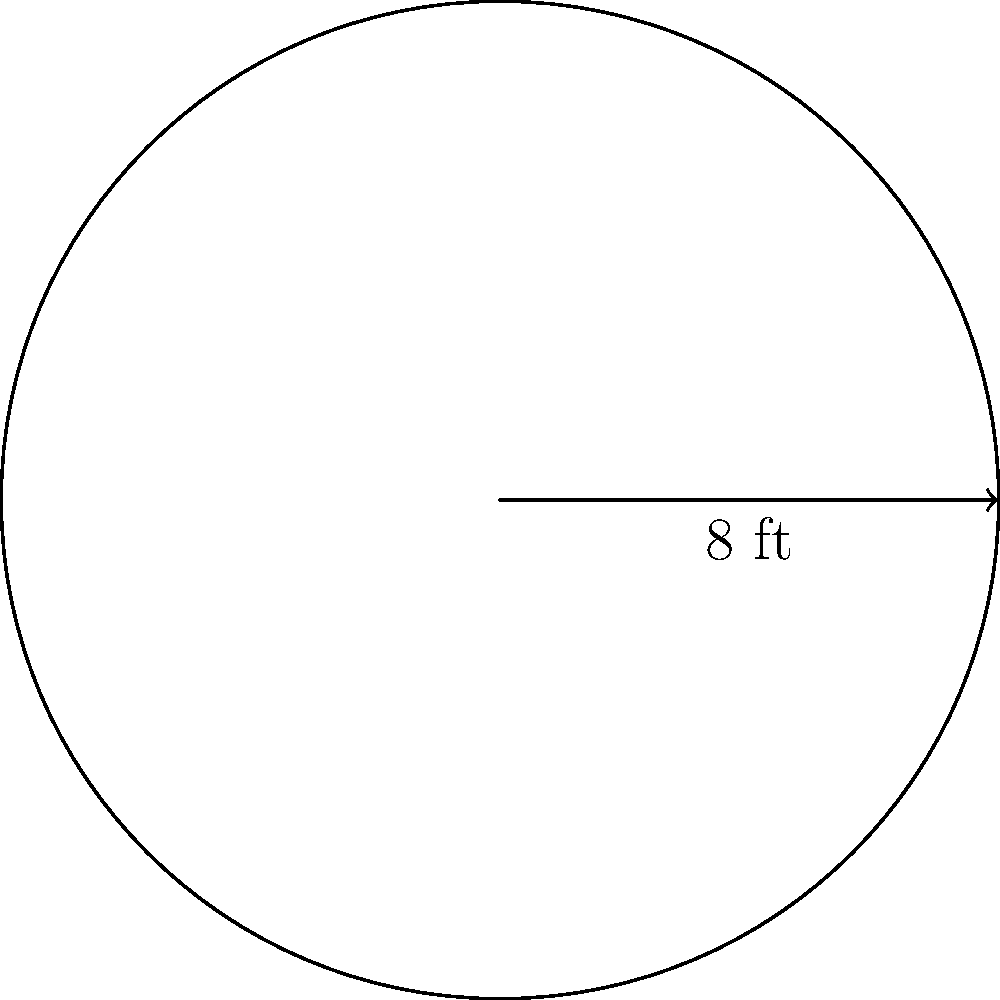As a proud American manufacturer, you're expanding your storage capacity. You need to calculate the floor area of a new circular storage tank for your Trump-supporting business. If the tank has a diameter of 8 feet, what is its floor area in square feet? Round your answer to the nearest whole number. Let's approach this step-by-step:

1) The formula for the area of a circle is $A = \pi r^2$, where $r$ is the radius.

2) We're given the diameter, which is 8 feet. The radius is half of the diameter:
   $r = 8 \div 2 = 4$ feet

3) Now, let's substitute this into our formula:
   $A = \pi (4)^2$

4) Simplify:
   $A = \pi (16)$
   $A = 16\pi$

5) Using $\pi \approx 3.14159$, we get:
   $A \approx 16 * 3.14159 = 50.26544$ square feet

6) Rounding to the nearest whole number:
   $A \approx 50$ square feet

This new storage tank will provide ample space for your American-made products!
Answer: 50 sq ft 